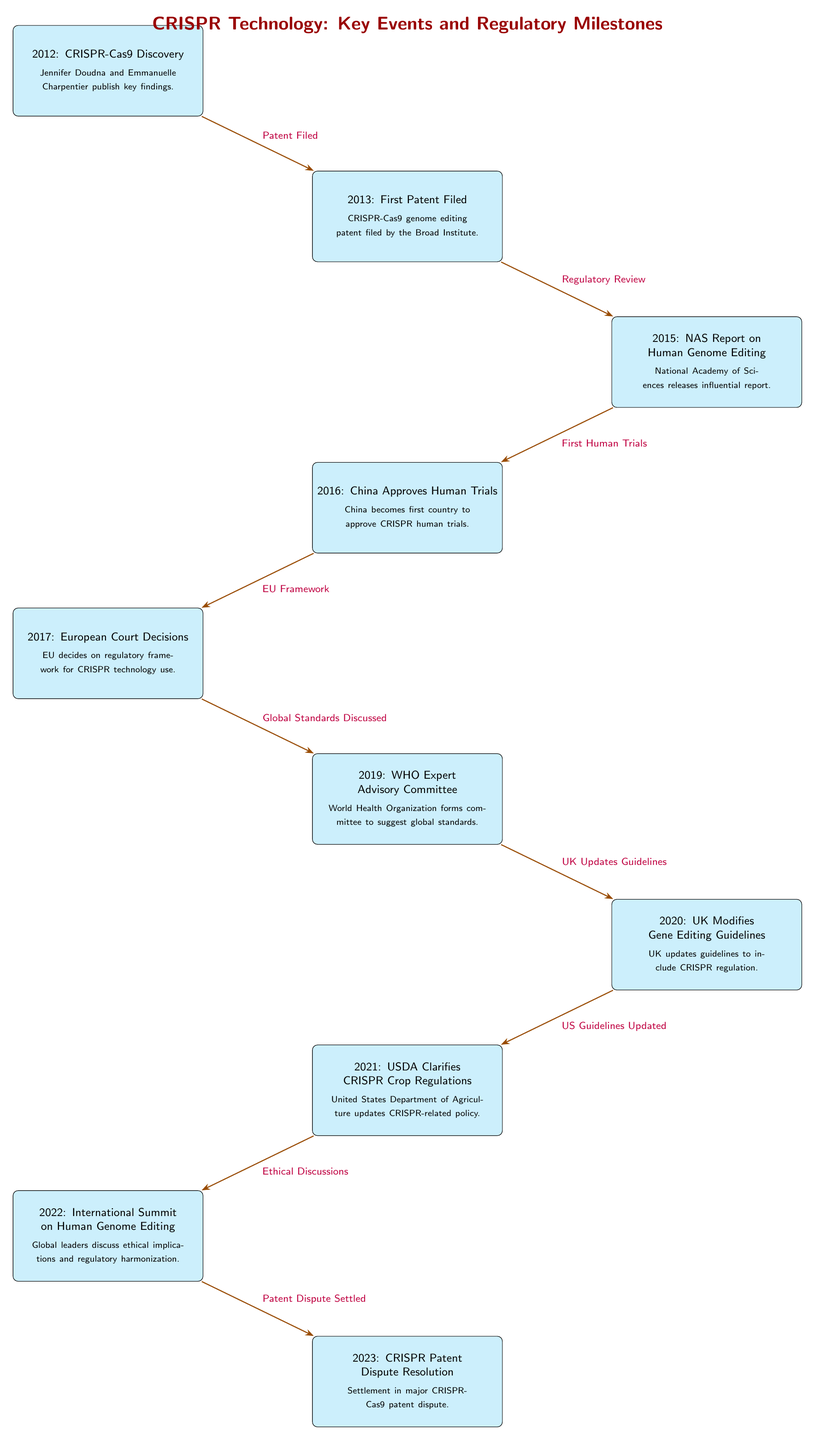What event marks the beginning of CRISPR-Cas9's journey? The timeline shows that the CRISPR-Cas9 journey begins with the discovery made by Jennifer Doudna and Emmanuelle Charpentier in 2012.
Answer: 2012: CRISPR-Cas9 Discovery What year did China approve human trials for CRISPR? According to the diagram, China became the first country to approve CRISPR human trials in 2016.
Answer: 2016: China Approves Human Trials How many events are depicted in the timeline? Counting all the key events shown in the timeline, there are a total of 10 events listed.
Answer: 10 Which event follows the National Academy of Sciences' report? The timeline indicates that after the NAS report on human genome editing in 2015, the next event is China's approval of human trials in 2016.
Answer: 2016: China Approves Human Trials What significant conclusion was drawn during the 2022 international summit? The diagram indicates that the 2022 summit focused on ethical implications and regulatory harmonization regarding CRISPR.
Answer: Ethical implications and regulatory harmonization What regulatory update was made by the UK in 2020? The timeline shows that in 2020, the UK modified its gene editing guidelines to include CRISPR regulation.
Answer: UK Modifies Gene Editing Guidelines Which two events are linked by the arrow labeled "First Human Trials"? The arrow labeled "First Human Trials" connects the NAS report from 2015 and China's approval of human trials in 2016.
Answer: 2015: NAS Report on Human Genome Editing and 2016: China Approves Human Trials What was the outcome of the 2023 event regarding CRISPR? The diagram indicates that the 2023 event resolved a major patent dispute concerning CRISPR-Cas9 technology.
Answer: Patent Dispute Resolution What event is discussed in connection with "Global Standards Discussed"? The event connected by the label "Global Standards Discussed" is the formation of the WHO Expert Advisory Committee in 2019.
Answer: 2019: WHO Expert Advisory Committee 